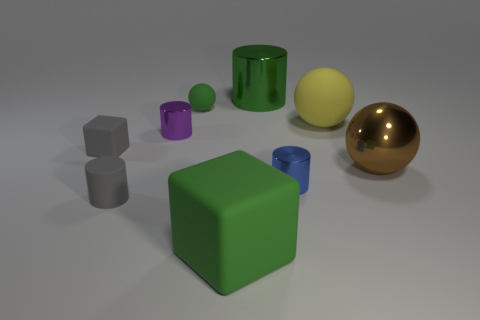Subtract all large metal balls. How many balls are left? 2 Subtract all yellow spheres. How many spheres are left? 2 Subtract all green cylinders. Subtract all brown cubes. How many cylinders are left? 3 Subtract 0 blue cubes. How many objects are left? 9 Subtract all spheres. How many objects are left? 6 Subtract all big purple shiny spheres. Subtract all green metal cylinders. How many objects are left? 8 Add 9 large yellow things. How many large yellow things are left? 10 Add 5 tiny matte cubes. How many tiny matte cubes exist? 6 